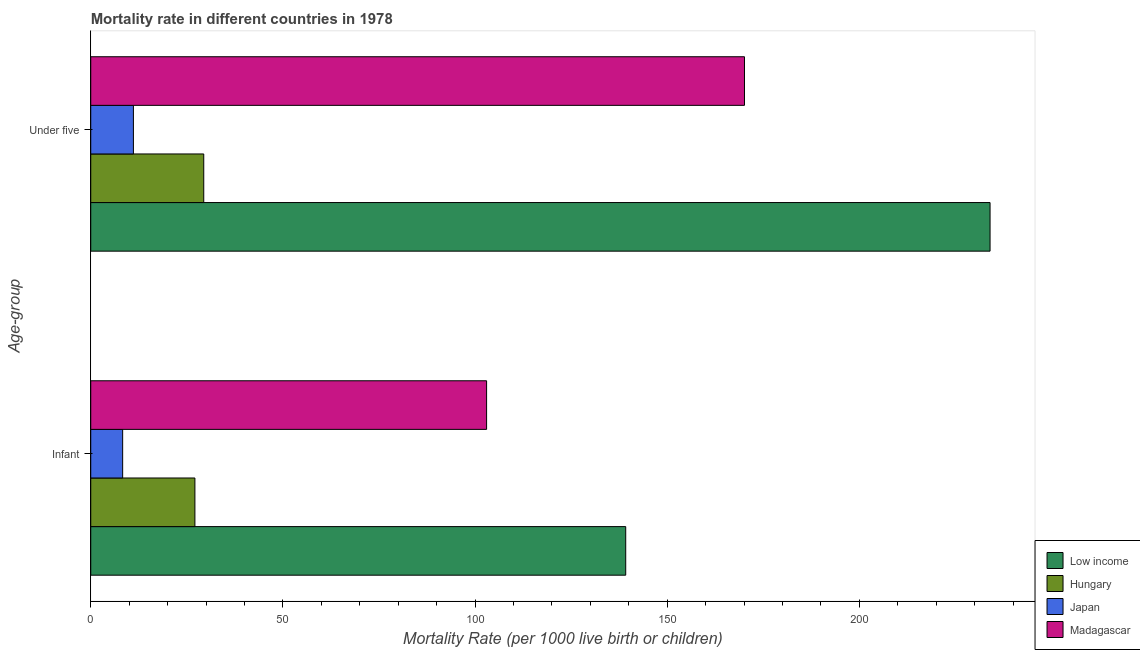How many groups of bars are there?
Keep it short and to the point. 2. How many bars are there on the 2nd tick from the bottom?
Make the answer very short. 4. What is the label of the 1st group of bars from the top?
Provide a succinct answer. Under five. What is the infant mortality rate in Hungary?
Your response must be concise. 27.1. Across all countries, what is the maximum under-5 mortality rate?
Provide a short and direct response. 234. Across all countries, what is the minimum under-5 mortality rate?
Your answer should be very brief. 11.1. In which country was the under-5 mortality rate minimum?
Offer a terse response. Japan. What is the total infant mortality rate in the graph?
Provide a short and direct response. 277.6. What is the difference between the infant mortality rate in Japan and that in Low income?
Your answer should be very brief. -130.9. What is the difference between the under-5 mortality rate in Japan and the infant mortality rate in Madagascar?
Keep it short and to the point. -91.9. What is the average infant mortality rate per country?
Offer a terse response. 69.4. What is the difference between the infant mortality rate and under-5 mortality rate in Low income?
Give a very brief answer. -94.8. What is the ratio of the under-5 mortality rate in Low income to that in Japan?
Keep it short and to the point. 21.08. What does the 4th bar from the bottom in Infant represents?
Keep it short and to the point. Madagascar. How many bars are there?
Keep it short and to the point. 8. How many countries are there in the graph?
Offer a very short reply. 4. What is the difference between two consecutive major ticks on the X-axis?
Keep it short and to the point. 50. Does the graph contain any zero values?
Keep it short and to the point. No. Where does the legend appear in the graph?
Your answer should be compact. Bottom right. How are the legend labels stacked?
Keep it short and to the point. Vertical. What is the title of the graph?
Ensure brevity in your answer.  Mortality rate in different countries in 1978. Does "Other small states" appear as one of the legend labels in the graph?
Your response must be concise. No. What is the label or title of the X-axis?
Offer a very short reply. Mortality Rate (per 1000 live birth or children). What is the label or title of the Y-axis?
Make the answer very short. Age-group. What is the Mortality Rate (per 1000 live birth or children) of Low income in Infant?
Ensure brevity in your answer.  139.2. What is the Mortality Rate (per 1000 live birth or children) of Hungary in Infant?
Give a very brief answer. 27.1. What is the Mortality Rate (per 1000 live birth or children) of Madagascar in Infant?
Make the answer very short. 103. What is the Mortality Rate (per 1000 live birth or children) of Low income in Under five?
Provide a succinct answer. 234. What is the Mortality Rate (per 1000 live birth or children) of Hungary in Under five?
Your answer should be very brief. 29.4. What is the Mortality Rate (per 1000 live birth or children) in Japan in Under five?
Your response must be concise. 11.1. What is the Mortality Rate (per 1000 live birth or children) in Madagascar in Under five?
Offer a terse response. 170.1. Across all Age-group, what is the maximum Mortality Rate (per 1000 live birth or children) of Low income?
Your answer should be very brief. 234. Across all Age-group, what is the maximum Mortality Rate (per 1000 live birth or children) of Hungary?
Offer a very short reply. 29.4. Across all Age-group, what is the maximum Mortality Rate (per 1000 live birth or children) in Madagascar?
Keep it short and to the point. 170.1. Across all Age-group, what is the minimum Mortality Rate (per 1000 live birth or children) in Low income?
Your response must be concise. 139.2. Across all Age-group, what is the minimum Mortality Rate (per 1000 live birth or children) of Hungary?
Your response must be concise. 27.1. Across all Age-group, what is the minimum Mortality Rate (per 1000 live birth or children) in Japan?
Ensure brevity in your answer.  8.3. Across all Age-group, what is the minimum Mortality Rate (per 1000 live birth or children) of Madagascar?
Make the answer very short. 103. What is the total Mortality Rate (per 1000 live birth or children) of Low income in the graph?
Offer a very short reply. 373.2. What is the total Mortality Rate (per 1000 live birth or children) of Hungary in the graph?
Ensure brevity in your answer.  56.5. What is the total Mortality Rate (per 1000 live birth or children) in Japan in the graph?
Your answer should be very brief. 19.4. What is the total Mortality Rate (per 1000 live birth or children) of Madagascar in the graph?
Offer a very short reply. 273.1. What is the difference between the Mortality Rate (per 1000 live birth or children) of Low income in Infant and that in Under five?
Give a very brief answer. -94.8. What is the difference between the Mortality Rate (per 1000 live birth or children) of Hungary in Infant and that in Under five?
Keep it short and to the point. -2.3. What is the difference between the Mortality Rate (per 1000 live birth or children) of Madagascar in Infant and that in Under five?
Your answer should be compact. -67.1. What is the difference between the Mortality Rate (per 1000 live birth or children) of Low income in Infant and the Mortality Rate (per 1000 live birth or children) of Hungary in Under five?
Make the answer very short. 109.8. What is the difference between the Mortality Rate (per 1000 live birth or children) in Low income in Infant and the Mortality Rate (per 1000 live birth or children) in Japan in Under five?
Keep it short and to the point. 128.1. What is the difference between the Mortality Rate (per 1000 live birth or children) in Low income in Infant and the Mortality Rate (per 1000 live birth or children) in Madagascar in Under five?
Your answer should be compact. -30.9. What is the difference between the Mortality Rate (per 1000 live birth or children) in Hungary in Infant and the Mortality Rate (per 1000 live birth or children) in Japan in Under five?
Your response must be concise. 16. What is the difference between the Mortality Rate (per 1000 live birth or children) of Hungary in Infant and the Mortality Rate (per 1000 live birth or children) of Madagascar in Under five?
Provide a short and direct response. -143. What is the difference between the Mortality Rate (per 1000 live birth or children) of Japan in Infant and the Mortality Rate (per 1000 live birth or children) of Madagascar in Under five?
Your answer should be very brief. -161.8. What is the average Mortality Rate (per 1000 live birth or children) in Low income per Age-group?
Ensure brevity in your answer.  186.6. What is the average Mortality Rate (per 1000 live birth or children) of Hungary per Age-group?
Your answer should be very brief. 28.25. What is the average Mortality Rate (per 1000 live birth or children) in Madagascar per Age-group?
Your answer should be compact. 136.55. What is the difference between the Mortality Rate (per 1000 live birth or children) of Low income and Mortality Rate (per 1000 live birth or children) of Hungary in Infant?
Ensure brevity in your answer.  112.1. What is the difference between the Mortality Rate (per 1000 live birth or children) of Low income and Mortality Rate (per 1000 live birth or children) of Japan in Infant?
Your answer should be very brief. 130.9. What is the difference between the Mortality Rate (per 1000 live birth or children) of Low income and Mortality Rate (per 1000 live birth or children) of Madagascar in Infant?
Offer a very short reply. 36.2. What is the difference between the Mortality Rate (per 1000 live birth or children) of Hungary and Mortality Rate (per 1000 live birth or children) of Madagascar in Infant?
Offer a terse response. -75.9. What is the difference between the Mortality Rate (per 1000 live birth or children) in Japan and Mortality Rate (per 1000 live birth or children) in Madagascar in Infant?
Your answer should be very brief. -94.7. What is the difference between the Mortality Rate (per 1000 live birth or children) in Low income and Mortality Rate (per 1000 live birth or children) in Hungary in Under five?
Your answer should be very brief. 204.6. What is the difference between the Mortality Rate (per 1000 live birth or children) of Low income and Mortality Rate (per 1000 live birth or children) of Japan in Under five?
Keep it short and to the point. 222.9. What is the difference between the Mortality Rate (per 1000 live birth or children) of Low income and Mortality Rate (per 1000 live birth or children) of Madagascar in Under five?
Provide a succinct answer. 63.9. What is the difference between the Mortality Rate (per 1000 live birth or children) of Hungary and Mortality Rate (per 1000 live birth or children) of Japan in Under five?
Your response must be concise. 18.3. What is the difference between the Mortality Rate (per 1000 live birth or children) of Hungary and Mortality Rate (per 1000 live birth or children) of Madagascar in Under five?
Give a very brief answer. -140.7. What is the difference between the Mortality Rate (per 1000 live birth or children) in Japan and Mortality Rate (per 1000 live birth or children) in Madagascar in Under five?
Provide a short and direct response. -159. What is the ratio of the Mortality Rate (per 1000 live birth or children) in Low income in Infant to that in Under five?
Your answer should be compact. 0.59. What is the ratio of the Mortality Rate (per 1000 live birth or children) in Hungary in Infant to that in Under five?
Ensure brevity in your answer.  0.92. What is the ratio of the Mortality Rate (per 1000 live birth or children) of Japan in Infant to that in Under five?
Your answer should be very brief. 0.75. What is the ratio of the Mortality Rate (per 1000 live birth or children) in Madagascar in Infant to that in Under five?
Make the answer very short. 0.61. What is the difference between the highest and the second highest Mortality Rate (per 1000 live birth or children) of Low income?
Offer a very short reply. 94.8. What is the difference between the highest and the second highest Mortality Rate (per 1000 live birth or children) of Madagascar?
Your answer should be compact. 67.1. What is the difference between the highest and the lowest Mortality Rate (per 1000 live birth or children) of Low income?
Make the answer very short. 94.8. What is the difference between the highest and the lowest Mortality Rate (per 1000 live birth or children) in Madagascar?
Your answer should be very brief. 67.1. 